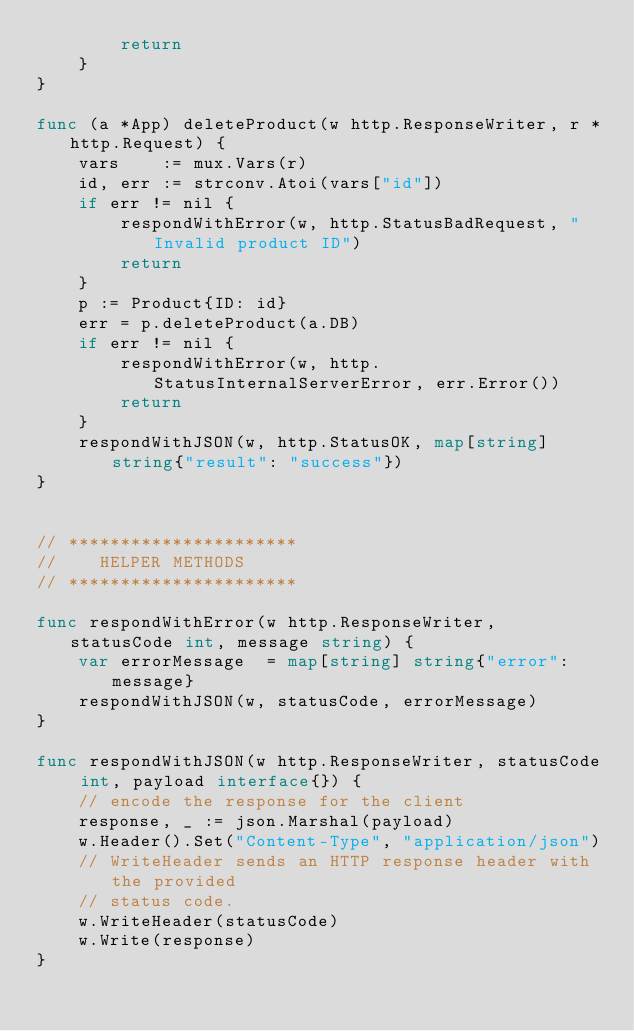<code> <loc_0><loc_0><loc_500><loc_500><_Go_>		return 
	}
}

func (a *App) deleteProduct(w http.ResponseWriter, r *http.Request) {
	vars    := mux.Vars(r)
	id, err := strconv.Atoi(vars["id"])
	if err != nil {
		respondWithError(w, http.StatusBadRequest, "Invalid product ID")
		return 
	}
	p := Product{ID: id}
	err = p.deleteProduct(a.DB)
	if err != nil {
		respondWithError(w, http.StatusInternalServerError, err.Error())
		return
	}
	respondWithJSON(w, http.StatusOK, map[string]string{"result": "success"})
}


// **********************
//    HELPER METHODS 
// **********************

func respondWithError(w http.ResponseWriter, statusCode int, message string) {
	var errorMessage  = map[string] string{"error": message}
	respondWithJSON(w, statusCode, errorMessage)
}

func respondWithJSON(w http.ResponseWriter, statusCode int, payload interface{}) {
	// encode the response for the client 
	response, _ := json.Marshal(payload)
	w.Header().Set("Content-Type", "application/json")
	// WriteHeader sends an HTTP response header with the provided
	// status code.
	w.WriteHeader(statusCode)
	w.Write(response)
}</code> 